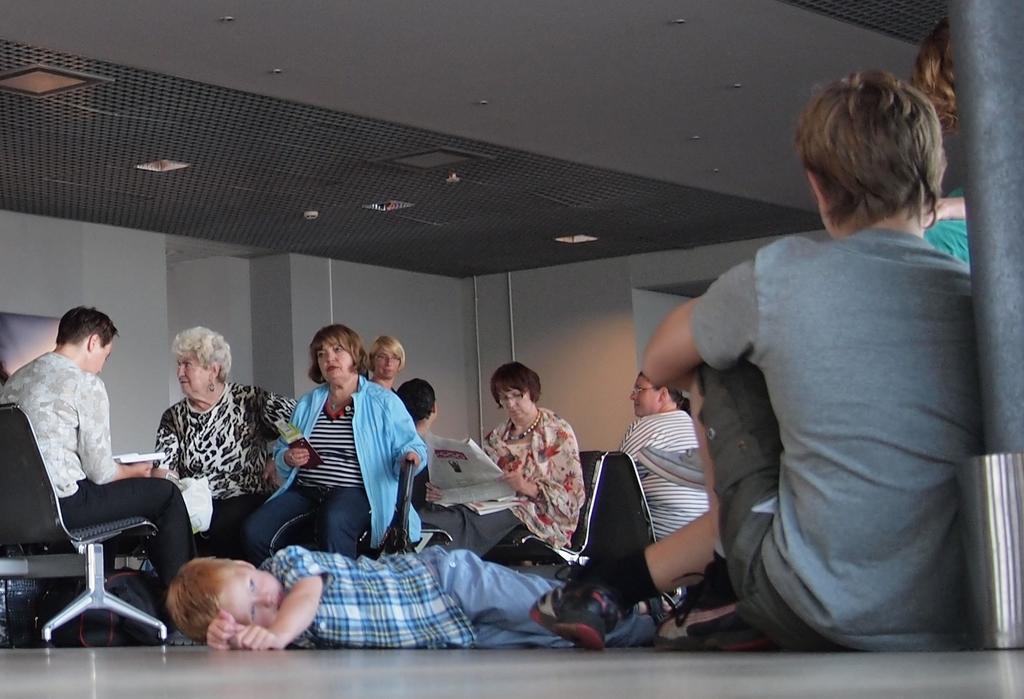Could you give a brief overview of what you see in this image? In this picture we can see some person sitting on chair and some are sitting on floor and some are sleeping on floor and in background we can see wall, pipe. 